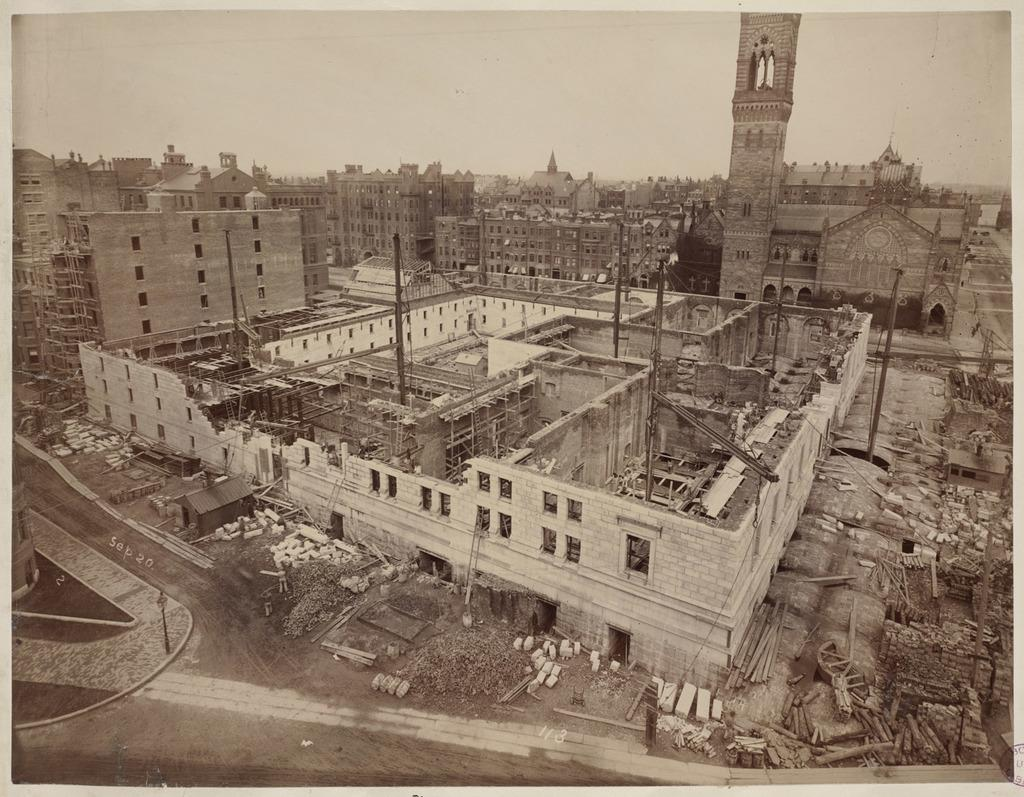What is the main subject of the image? The main subject of the image is demolished buildings. Can you describe the surrounding area in the image? There are other buildings visible in the background. What is the condition of the sky in the image? The sky is clear in the image. Can you tell me how many people are standing on the demolished buildings in the image? There are no people visible on the demolished buildings in the image. What type of view can be seen from the top of the demolished buildings in the image? There is no view visible from the top of the demolished buildings in the image, as they are not tall enough to provide a view. 